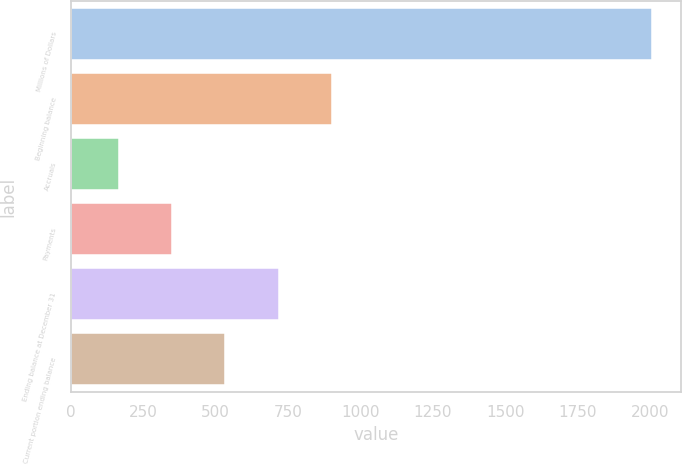Convert chart to OTSL. <chart><loc_0><loc_0><loc_500><loc_500><bar_chart><fcel>Millions of Dollars<fcel>Beginning balance<fcel>Accruals<fcel>Payments<fcel>Ending balance at December 31<fcel>Current portion ending balance<nl><fcel>2007<fcel>901.8<fcel>165<fcel>349.2<fcel>717.6<fcel>533.4<nl></chart> 